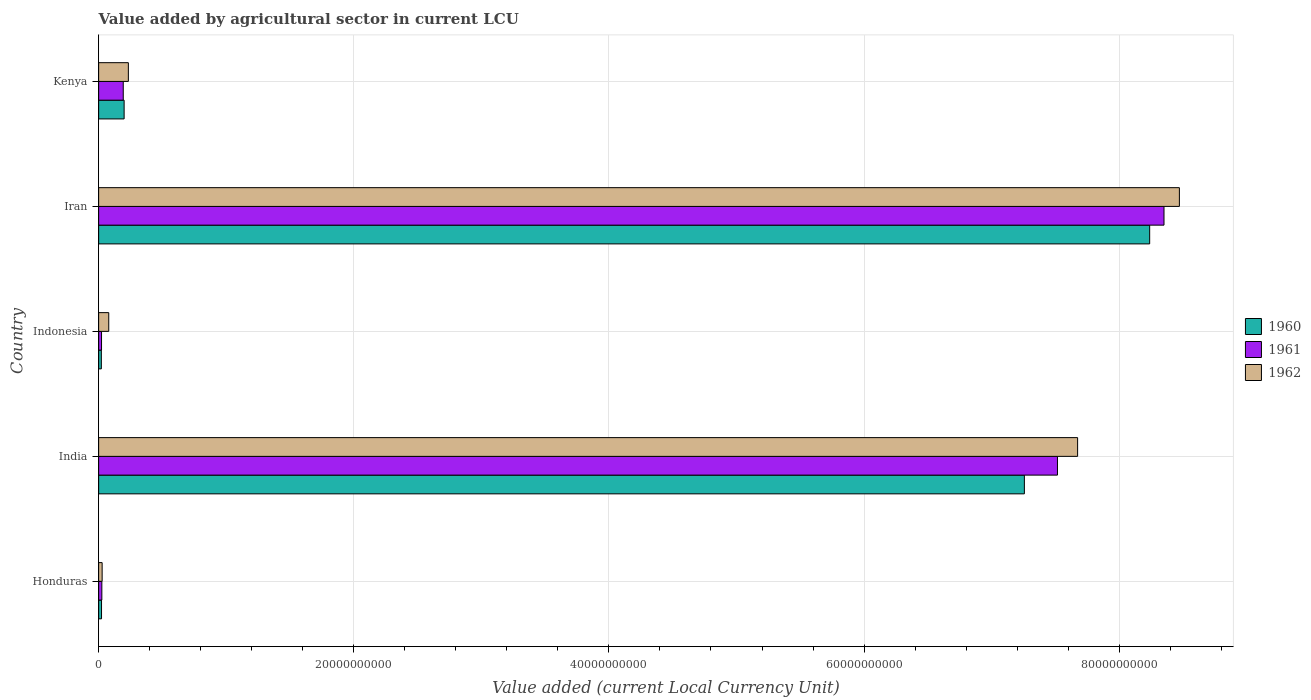Are the number of bars on each tick of the Y-axis equal?
Offer a very short reply. Yes. What is the label of the 2nd group of bars from the top?
Ensure brevity in your answer.  Iran. What is the value added by agricultural sector in 1960 in Iran?
Make the answer very short. 8.24e+1. Across all countries, what is the maximum value added by agricultural sector in 1961?
Offer a terse response. 8.35e+1. Across all countries, what is the minimum value added by agricultural sector in 1962?
Ensure brevity in your answer.  2.74e+08. In which country was the value added by agricultural sector in 1960 maximum?
Offer a very short reply. Iran. What is the total value added by agricultural sector in 1961 in the graph?
Provide a short and direct response. 1.61e+11. What is the difference between the value added by agricultural sector in 1962 in India and that in Kenya?
Offer a terse response. 7.44e+1. What is the difference between the value added by agricultural sector in 1962 in Iran and the value added by agricultural sector in 1960 in Indonesia?
Offer a very short reply. 8.45e+1. What is the average value added by agricultural sector in 1961 per country?
Keep it short and to the point. 3.22e+1. What is the difference between the value added by agricultural sector in 1962 and value added by agricultural sector in 1960 in India?
Your answer should be compact. 4.17e+09. In how many countries, is the value added by agricultural sector in 1961 greater than 76000000000 LCU?
Provide a succinct answer. 1. What is the ratio of the value added by agricultural sector in 1960 in Honduras to that in Kenya?
Give a very brief answer. 0.11. Is the difference between the value added by agricultural sector in 1962 in Honduras and India greater than the difference between the value added by agricultural sector in 1960 in Honduras and India?
Ensure brevity in your answer.  No. What is the difference between the highest and the second highest value added by agricultural sector in 1961?
Offer a terse response. 8.35e+09. What is the difference between the highest and the lowest value added by agricultural sector in 1960?
Your answer should be very brief. 8.22e+1. In how many countries, is the value added by agricultural sector in 1960 greater than the average value added by agricultural sector in 1960 taken over all countries?
Your answer should be compact. 2. Is the sum of the value added by agricultural sector in 1960 in Honduras and Indonesia greater than the maximum value added by agricultural sector in 1961 across all countries?
Give a very brief answer. No. What does the 1st bar from the top in Indonesia represents?
Offer a terse response. 1962. What does the 3rd bar from the bottom in Indonesia represents?
Give a very brief answer. 1962. Are all the bars in the graph horizontal?
Provide a short and direct response. Yes. Are the values on the major ticks of X-axis written in scientific E-notation?
Give a very brief answer. No. Does the graph contain grids?
Your response must be concise. Yes. What is the title of the graph?
Provide a succinct answer. Value added by agricultural sector in current LCU. What is the label or title of the X-axis?
Provide a succinct answer. Value added (current Local Currency Unit). What is the Value added (current Local Currency Unit) of 1960 in Honduras?
Make the answer very short. 2.27e+08. What is the Value added (current Local Currency Unit) in 1961 in Honduras?
Offer a terse response. 2.51e+08. What is the Value added (current Local Currency Unit) in 1962 in Honduras?
Your answer should be very brief. 2.74e+08. What is the Value added (current Local Currency Unit) of 1960 in India?
Make the answer very short. 7.26e+1. What is the Value added (current Local Currency Unit) of 1961 in India?
Your answer should be compact. 7.52e+1. What is the Value added (current Local Currency Unit) in 1962 in India?
Provide a short and direct response. 7.67e+1. What is the Value added (current Local Currency Unit) of 1960 in Indonesia?
Offer a terse response. 2.12e+08. What is the Value added (current Local Currency Unit) of 1961 in Indonesia?
Your response must be concise. 2.27e+08. What is the Value added (current Local Currency Unit) in 1962 in Indonesia?
Provide a short and direct response. 7.93e+08. What is the Value added (current Local Currency Unit) in 1960 in Iran?
Your response must be concise. 8.24e+1. What is the Value added (current Local Currency Unit) in 1961 in Iran?
Ensure brevity in your answer.  8.35e+1. What is the Value added (current Local Currency Unit) of 1962 in Iran?
Offer a terse response. 8.47e+1. What is the Value added (current Local Currency Unit) of 1960 in Kenya?
Offer a very short reply. 2.00e+09. What is the Value added (current Local Currency Unit) in 1961 in Kenya?
Your answer should be compact. 1.93e+09. What is the Value added (current Local Currency Unit) of 1962 in Kenya?
Your answer should be very brief. 2.33e+09. Across all countries, what is the maximum Value added (current Local Currency Unit) in 1960?
Provide a succinct answer. 8.24e+1. Across all countries, what is the maximum Value added (current Local Currency Unit) in 1961?
Your answer should be very brief. 8.35e+1. Across all countries, what is the maximum Value added (current Local Currency Unit) of 1962?
Offer a terse response. 8.47e+1. Across all countries, what is the minimum Value added (current Local Currency Unit) of 1960?
Keep it short and to the point. 2.12e+08. Across all countries, what is the minimum Value added (current Local Currency Unit) in 1961?
Provide a short and direct response. 2.27e+08. Across all countries, what is the minimum Value added (current Local Currency Unit) in 1962?
Make the answer very short. 2.74e+08. What is the total Value added (current Local Currency Unit) in 1960 in the graph?
Offer a terse response. 1.57e+11. What is the total Value added (current Local Currency Unit) in 1961 in the graph?
Offer a terse response. 1.61e+11. What is the total Value added (current Local Currency Unit) of 1962 in the graph?
Give a very brief answer. 1.65e+11. What is the difference between the Value added (current Local Currency Unit) in 1960 in Honduras and that in India?
Your response must be concise. -7.23e+1. What is the difference between the Value added (current Local Currency Unit) in 1961 in Honduras and that in India?
Your answer should be compact. -7.49e+1. What is the difference between the Value added (current Local Currency Unit) of 1962 in Honduras and that in India?
Make the answer very short. -7.65e+1. What is the difference between the Value added (current Local Currency Unit) in 1960 in Honduras and that in Indonesia?
Ensure brevity in your answer.  1.50e+07. What is the difference between the Value added (current Local Currency Unit) in 1961 in Honduras and that in Indonesia?
Make the answer very short. 2.42e+07. What is the difference between the Value added (current Local Currency Unit) of 1962 in Honduras and that in Indonesia?
Keep it short and to the point. -5.18e+08. What is the difference between the Value added (current Local Currency Unit) in 1960 in Honduras and that in Iran?
Keep it short and to the point. -8.22e+1. What is the difference between the Value added (current Local Currency Unit) of 1961 in Honduras and that in Iran?
Ensure brevity in your answer.  -8.33e+1. What is the difference between the Value added (current Local Currency Unit) of 1962 in Honduras and that in Iran?
Offer a very short reply. -8.44e+1. What is the difference between the Value added (current Local Currency Unit) in 1960 in Honduras and that in Kenya?
Your answer should be compact. -1.77e+09. What is the difference between the Value added (current Local Currency Unit) of 1961 in Honduras and that in Kenya?
Offer a terse response. -1.68e+09. What is the difference between the Value added (current Local Currency Unit) in 1962 in Honduras and that in Kenya?
Offer a terse response. -2.06e+09. What is the difference between the Value added (current Local Currency Unit) in 1960 in India and that in Indonesia?
Offer a terse response. 7.24e+1. What is the difference between the Value added (current Local Currency Unit) of 1961 in India and that in Indonesia?
Give a very brief answer. 7.49e+1. What is the difference between the Value added (current Local Currency Unit) in 1962 in India and that in Indonesia?
Ensure brevity in your answer.  7.59e+1. What is the difference between the Value added (current Local Currency Unit) in 1960 in India and that in Iran?
Make the answer very short. -9.82e+09. What is the difference between the Value added (current Local Currency Unit) of 1961 in India and that in Iran?
Offer a terse response. -8.35e+09. What is the difference between the Value added (current Local Currency Unit) in 1962 in India and that in Iran?
Your answer should be very brief. -7.98e+09. What is the difference between the Value added (current Local Currency Unit) of 1960 in India and that in Kenya?
Keep it short and to the point. 7.06e+1. What is the difference between the Value added (current Local Currency Unit) of 1961 in India and that in Kenya?
Your response must be concise. 7.32e+1. What is the difference between the Value added (current Local Currency Unit) of 1962 in India and that in Kenya?
Offer a very short reply. 7.44e+1. What is the difference between the Value added (current Local Currency Unit) in 1960 in Indonesia and that in Iran?
Provide a short and direct response. -8.22e+1. What is the difference between the Value added (current Local Currency Unit) of 1961 in Indonesia and that in Iran?
Provide a succinct answer. -8.33e+1. What is the difference between the Value added (current Local Currency Unit) in 1962 in Indonesia and that in Iran?
Offer a terse response. -8.39e+1. What is the difference between the Value added (current Local Currency Unit) in 1960 in Indonesia and that in Kenya?
Offer a terse response. -1.79e+09. What is the difference between the Value added (current Local Currency Unit) in 1961 in Indonesia and that in Kenya?
Provide a short and direct response. -1.70e+09. What is the difference between the Value added (current Local Currency Unit) in 1962 in Indonesia and that in Kenya?
Make the answer very short. -1.54e+09. What is the difference between the Value added (current Local Currency Unit) in 1960 in Iran and that in Kenya?
Give a very brief answer. 8.04e+1. What is the difference between the Value added (current Local Currency Unit) in 1961 in Iran and that in Kenya?
Give a very brief answer. 8.16e+1. What is the difference between the Value added (current Local Currency Unit) of 1962 in Iran and that in Kenya?
Ensure brevity in your answer.  8.24e+1. What is the difference between the Value added (current Local Currency Unit) of 1960 in Honduras and the Value added (current Local Currency Unit) of 1961 in India?
Your answer should be compact. -7.49e+1. What is the difference between the Value added (current Local Currency Unit) of 1960 in Honduras and the Value added (current Local Currency Unit) of 1962 in India?
Provide a short and direct response. -7.65e+1. What is the difference between the Value added (current Local Currency Unit) in 1961 in Honduras and the Value added (current Local Currency Unit) in 1962 in India?
Offer a terse response. -7.65e+1. What is the difference between the Value added (current Local Currency Unit) of 1960 in Honduras and the Value added (current Local Currency Unit) of 1962 in Indonesia?
Keep it short and to the point. -5.66e+08. What is the difference between the Value added (current Local Currency Unit) in 1961 in Honduras and the Value added (current Local Currency Unit) in 1962 in Indonesia?
Make the answer very short. -5.42e+08. What is the difference between the Value added (current Local Currency Unit) of 1960 in Honduras and the Value added (current Local Currency Unit) of 1961 in Iran?
Provide a succinct answer. -8.33e+1. What is the difference between the Value added (current Local Currency Unit) of 1960 in Honduras and the Value added (current Local Currency Unit) of 1962 in Iran?
Provide a succinct answer. -8.45e+1. What is the difference between the Value added (current Local Currency Unit) in 1961 in Honduras and the Value added (current Local Currency Unit) in 1962 in Iran?
Offer a very short reply. -8.45e+1. What is the difference between the Value added (current Local Currency Unit) in 1960 in Honduras and the Value added (current Local Currency Unit) in 1961 in Kenya?
Make the answer very short. -1.70e+09. What is the difference between the Value added (current Local Currency Unit) in 1960 in Honduras and the Value added (current Local Currency Unit) in 1962 in Kenya?
Your answer should be very brief. -2.10e+09. What is the difference between the Value added (current Local Currency Unit) in 1961 in Honduras and the Value added (current Local Currency Unit) in 1962 in Kenya?
Provide a short and direct response. -2.08e+09. What is the difference between the Value added (current Local Currency Unit) of 1960 in India and the Value added (current Local Currency Unit) of 1961 in Indonesia?
Offer a terse response. 7.23e+1. What is the difference between the Value added (current Local Currency Unit) in 1960 in India and the Value added (current Local Currency Unit) in 1962 in Indonesia?
Your answer should be very brief. 7.18e+1. What is the difference between the Value added (current Local Currency Unit) of 1961 in India and the Value added (current Local Currency Unit) of 1962 in Indonesia?
Your answer should be compact. 7.44e+1. What is the difference between the Value added (current Local Currency Unit) in 1960 in India and the Value added (current Local Currency Unit) in 1961 in Iran?
Your answer should be compact. -1.09e+1. What is the difference between the Value added (current Local Currency Unit) in 1960 in India and the Value added (current Local Currency Unit) in 1962 in Iran?
Provide a succinct answer. -1.22e+1. What is the difference between the Value added (current Local Currency Unit) of 1961 in India and the Value added (current Local Currency Unit) of 1962 in Iran?
Your response must be concise. -9.56e+09. What is the difference between the Value added (current Local Currency Unit) of 1960 in India and the Value added (current Local Currency Unit) of 1961 in Kenya?
Your response must be concise. 7.06e+1. What is the difference between the Value added (current Local Currency Unit) of 1960 in India and the Value added (current Local Currency Unit) of 1962 in Kenya?
Offer a terse response. 7.02e+1. What is the difference between the Value added (current Local Currency Unit) in 1961 in India and the Value added (current Local Currency Unit) in 1962 in Kenya?
Make the answer very short. 7.28e+1. What is the difference between the Value added (current Local Currency Unit) of 1960 in Indonesia and the Value added (current Local Currency Unit) of 1961 in Iran?
Your answer should be compact. -8.33e+1. What is the difference between the Value added (current Local Currency Unit) in 1960 in Indonesia and the Value added (current Local Currency Unit) in 1962 in Iran?
Provide a short and direct response. -8.45e+1. What is the difference between the Value added (current Local Currency Unit) of 1961 in Indonesia and the Value added (current Local Currency Unit) of 1962 in Iran?
Provide a succinct answer. -8.45e+1. What is the difference between the Value added (current Local Currency Unit) in 1960 in Indonesia and the Value added (current Local Currency Unit) in 1961 in Kenya?
Provide a succinct answer. -1.72e+09. What is the difference between the Value added (current Local Currency Unit) in 1960 in Indonesia and the Value added (current Local Currency Unit) in 1962 in Kenya?
Ensure brevity in your answer.  -2.12e+09. What is the difference between the Value added (current Local Currency Unit) in 1961 in Indonesia and the Value added (current Local Currency Unit) in 1962 in Kenya?
Give a very brief answer. -2.10e+09. What is the difference between the Value added (current Local Currency Unit) of 1960 in Iran and the Value added (current Local Currency Unit) of 1961 in Kenya?
Keep it short and to the point. 8.05e+1. What is the difference between the Value added (current Local Currency Unit) of 1960 in Iran and the Value added (current Local Currency Unit) of 1962 in Kenya?
Offer a very short reply. 8.01e+1. What is the difference between the Value added (current Local Currency Unit) in 1961 in Iran and the Value added (current Local Currency Unit) in 1962 in Kenya?
Provide a succinct answer. 8.12e+1. What is the average Value added (current Local Currency Unit) in 1960 per country?
Offer a terse response. 3.15e+1. What is the average Value added (current Local Currency Unit) of 1961 per country?
Your response must be concise. 3.22e+1. What is the average Value added (current Local Currency Unit) of 1962 per country?
Ensure brevity in your answer.  3.30e+1. What is the difference between the Value added (current Local Currency Unit) in 1960 and Value added (current Local Currency Unit) in 1961 in Honduras?
Provide a succinct answer. -2.42e+07. What is the difference between the Value added (current Local Currency Unit) of 1960 and Value added (current Local Currency Unit) of 1962 in Honduras?
Offer a terse response. -4.75e+07. What is the difference between the Value added (current Local Currency Unit) in 1961 and Value added (current Local Currency Unit) in 1962 in Honduras?
Provide a succinct answer. -2.33e+07. What is the difference between the Value added (current Local Currency Unit) of 1960 and Value added (current Local Currency Unit) of 1961 in India?
Your response must be concise. -2.59e+09. What is the difference between the Value added (current Local Currency Unit) of 1960 and Value added (current Local Currency Unit) of 1962 in India?
Provide a succinct answer. -4.17e+09. What is the difference between the Value added (current Local Currency Unit) of 1961 and Value added (current Local Currency Unit) of 1962 in India?
Ensure brevity in your answer.  -1.58e+09. What is the difference between the Value added (current Local Currency Unit) in 1960 and Value added (current Local Currency Unit) in 1961 in Indonesia?
Ensure brevity in your answer.  -1.50e+07. What is the difference between the Value added (current Local Currency Unit) in 1960 and Value added (current Local Currency Unit) in 1962 in Indonesia?
Keep it short and to the point. -5.81e+08. What is the difference between the Value added (current Local Currency Unit) of 1961 and Value added (current Local Currency Unit) of 1962 in Indonesia?
Keep it short and to the point. -5.66e+08. What is the difference between the Value added (current Local Currency Unit) in 1960 and Value added (current Local Currency Unit) in 1961 in Iran?
Offer a terse response. -1.12e+09. What is the difference between the Value added (current Local Currency Unit) in 1960 and Value added (current Local Currency Unit) in 1962 in Iran?
Your answer should be compact. -2.33e+09. What is the difference between the Value added (current Local Currency Unit) in 1961 and Value added (current Local Currency Unit) in 1962 in Iran?
Your answer should be very brief. -1.21e+09. What is the difference between the Value added (current Local Currency Unit) in 1960 and Value added (current Local Currency Unit) in 1961 in Kenya?
Offer a terse response. 6.79e+07. What is the difference between the Value added (current Local Currency Unit) of 1960 and Value added (current Local Currency Unit) of 1962 in Kenya?
Your answer should be very brief. -3.32e+08. What is the difference between the Value added (current Local Currency Unit) of 1961 and Value added (current Local Currency Unit) of 1962 in Kenya?
Your answer should be very brief. -4.00e+08. What is the ratio of the Value added (current Local Currency Unit) in 1960 in Honduras to that in India?
Your response must be concise. 0. What is the ratio of the Value added (current Local Currency Unit) of 1961 in Honduras to that in India?
Your answer should be compact. 0. What is the ratio of the Value added (current Local Currency Unit) of 1962 in Honduras to that in India?
Give a very brief answer. 0. What is the ratio of the Value added (current Local Currency Unit) of 1960 in Honduras to that in Indonesia?
Provide a succinct answer. 1.07. What is the ratio of the Value added (current Local Currency Unit) of 1961 in Honduras to that in Indonesia?
Your answer should be very brief. 1.11. What is the ratio of the Value added (current Local Currency Unit) in 1962 in Honduras to that in Indonesia?
Give a very brief answer. 0.35. What is the ratio of the Value added (current Local Currency Unit) of 1960 in Honduras to that in Iran?
Your answer should be compact. 0. What is the ratio of the Value added (current Local Currency Unit) of 1961 in Honduras to that in Iran?
Make the answer very short. 0. What is the ratio of the Value added (current Local Currency Unit) in 1962 in Honduras to that in Iran?
Your response must be concise. 0. What is the ratio of the Value added (current Local Currency Unit) of 1960 in Honduras to that in Kenya?
Keep it short and to the point. 0.11. What is the ratio of the Value added (current Local Currency Unit) of 1961 in Honduras to that in Kenya?
Offer a terse response. 0.13. What is the ratio of the Value added (current Local Currency Unit) of 1962 in Honduras to that in Kenya?
Keep it short and to the point. 0.12. What is the ratio of the Value added (current Local Currency Unit) in 1960 in India to that in Indonesia?
Provide a short and direct response. 342.29. What is the ratio of the Value added (current Local Currency Unit) in 1961 in India to that in Indonesia?
Give a very brief answer. 331.1. What is the ratio of the Value added (current Local Currency Unit) of 1962 in India to that in Indonesia?
Offer a terse response. 96.77. What is the ratio of the Value added (current Local Currency Unit) in 1960 in India to that in Iran?
Make the answer very short. 0.88. What is the ratio of the Value added (current Local Currency Unit) of 1962 in India to that in Iran?
Offer a terse response. 0.91. What is the ratio of the Value added (current Local Currency Unit) of 1960 in India to that in Kenya?
Your response must be concise. 36.32. What is the ratio of the Value added (current Local Currency Unit) of 1961 in India to that in Kenya?
Provide a short and direct response. 38.94. What is the ratio of the Value added (current Local Currency Unit) in 1962 in India to that in Kenya?
Your answer should be compact. 32.94. What is the ratio of the Value added (current Local Currency Unit) in 1960 in Indonesia to that in Iran?
Your answer should be very brief. 0. What is the ratio of the Value added (current Local Currency Unit) of 1961 in Indonesia to that in Iran?
Give a very brief answer. 0. What is the ratio of the Value added (current Local Currency Unit) in 1962 in Indonesia to that in Iran?
Offer a terse response. 0.01. What is the ratio of the Value added (current Local Currency Unit) of 1960 in Indonesia to that in Kenya?
Offer a terse response. 0.11. What is the ratio of the Value added (current Local Currency Unit) of 1961 in Indonesia to that in Kenya?
Give a very brief answer. 0.12. What is the ratio of the Value added (current Local Currency Unit) of 1962 in Indonesia to that in Kenya?
Provide a short and direct response. 0.34. What is the ratio of the Value added (current Local Currency Unit) in 1960 in Iran to that in Kenya?
Offer a very short reply. 41.24. What is the ratio of the Value added (current Local Currency Unit) of 1961 in Iran to that in Kenya?
Your response must be concise. 43.27. What is the ratio of the Value added (current Local Currency Unit) of 1962 in Iran to that in Kenya?
Make the answer very short. 36.36. What is the difference between the highest and the second highest Value added (current Local Currency Unit) in 1960?
Your response must be concise. 9.82e+09. What is the difference between the highest and the second highest Value added (current Local Currency Unit) of 1961?
Offer a very short reply. 8.35e+09. What is the difference between the highest and the second highest Value added (current Local Currency Unit) of 1962?
Your answer should be very brief. 7.98e+09. What is the difference between the highest and the lowest Value added (current Local Currency Unit) of 1960?
Your answer should be compact. 8.22e+1. What is the difference between the highest and the lowest Value added (current Local Currency Unit) of 1961?
Offer a very short reply. 8.33e+1. What is the difference between the highest and the lowest Value added (current Local Currency Unit) of 1962?
Keep it short and to the point. 8.44e+1. 